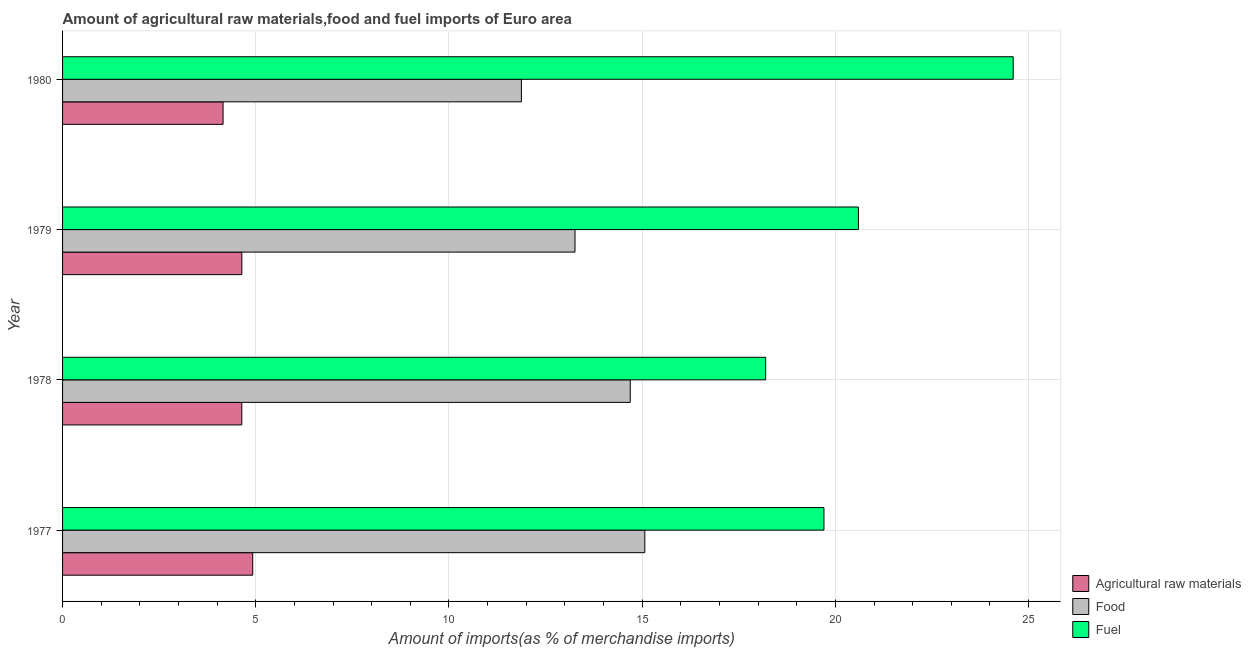Are the number of bars per tick equal to the number of legend labels?
Give a very brief answer. Yes. Are the number of bars on each tick of the Y-axis equal?
Offer a very short reply. Yes. How many bars are there on the 3rd tick from the top?
Provide a succinct answer. 3. What is the label of the 4th group of bars from the top?
Your answer should be compact. 1977. What is the percentage of food imports in 1978?
Your answer should be compact. 14.69. Across all years, what is the maximum percentage of food imports?
Offer a very short reply. 15.07. Across all years, what is the minimum percentage of raw materials imports?
Your answer should be compact. 4.15. What is the total percentage of food imports in the graph?
Give a very brief answer. 54.9. What is the difference between the percentage of raw materials imports in 1978 and that in 1980?
Offer a terse response. 0.48. What is the difference between the percentage of raw materials imports in 1979 and the percentage of fuel imports in 1980?
Offer a very short reply. -19.96. What is the average percentage of food imports per year?
Your response must be concise. 13.72. In the year 1979, what is the difference between the percentage of fuel imports and percentage of food imports?
Offer a terse response. 7.33. What is the ratio of the percentage of food imports in 1979 to that in 1980?
Provide a short and direct response. 1.12. Is the percentage of food imports in 1979 less than that in 1980?
Provide a short and direct response. No. What is the difference between the highest and the second highest percentage of food imports?
Offer a terse response. 0.38. What is the difference between the highest and the lowest percentage of fuel imports?
Offer a terse response. 6.41. In how many years, is the percentage of raw materials imports greater than the average percentage of raw materials imports taken over all years?
Your answer should be compact. 3. What does the 1st bar from the top in 1980 represents?
Keep it short and to the point. Fuel. What does the 2nd bar from the bottom in 1980 represents?
Give a very brief answer. Food. Is it the case that in every year, the sum of the percentage of raw materials imports and percentage of food imports is greater than the percentage of fuel imports?
Offer a terse response. No. How many years are there in the graph?
Give a very brief answer. 4. Where does the legend appear in the graph?
Keep it short and to the point. Bottom right. How many legend labels are there?
Make the answer very short. 3. How are the legend labels stacked?
Give a very brief answer. Vertical. What is the title of the graph?
Keep it short and to the point. Amount of agricultural raw materials,food and fuel imports of Euro area. What is the label or title of the X-axis?
Your answer should be compact. Amount of imports(as % of merchandise imports). What is the Amount of imports(as % of merchandise imports) in Agricultural raw materials in 1977?
Your response must be concise. 4.92. What is the Amount of imports(as % of merchandise imports) in Food in 1977?
Give a very brief answer. 15.07. What is the Amount of imports(as % of merchandise imports) in Fuel in 1977?
Provide a succinct answer. 19.7. What is the Amount of imports(as % of merchandise imports) of Agricultural raw materials in 1978?
Keep it short and to the point. 4.64. What is the Amount of imports(as % of merchandise imports) in Food in 1978?
Keep it short and to the point. 14.69. What is the Amount of imports(as % of merchandise imports) in Fuel in 1978?
Your answer should be very brief. 18.2. What is the Amount of imports(as % of merchandise imports) of Agricultural raw materials in 1979?
Provide a short and direct response. 4.64. What is the Amount of imports(as % of merchandise imports) in Food in 1979?
Give a very brief answer. 13.26. What is the Amount of imports(as % of merchandise imports) of Fuel in 1979?
Give a very brief answer. 20.6. What is the Amount of imports(as % of merchandise imports) of Agricultural raw materials in 1980?
Provide a short and direct response. 4.15. What is the Amount of imports(as % of merchandise imports) in Food in 1980?
Your response must be concise. 11.87. What is the Amount of imports(as % of merchandise imports) in Fuel in 1980?
Your response must be concise. 24.6. Across all years, what is the maximum Amount of imports(as % of merchandise imports) in Agricultural raw materials?
Keep it short and to the point. 4.92. Across all years, what is the maximum Amount of imports(as % of merchandise imports) in Food?
Offer a terse response. 15.07. Across all years, what is the maximum Amount of imports(as % of merchandise imports) in Fuel?
Provide a short and direct response. 24.6. Across all years, what is the minimum Amount of imports(as % of merchandise imports) in Agricultural raw materials?
Provide a short and direct response. 4.15. Across all years, what is the minimum Amount of imports(as % of merchandise imports) of Food?
Keep it short and to the point. 11.87. Across all years, what is the minimum Amount of imports(as % of merchandise imports) of Fuel?
Ensure brevity in your answer.  18.2. What is the total Amount of imports(as % of merchandise imports) of Agricultural raw materials in the graph?
Your answer should be compact. 18.35. What is the total Amount of imports(as % of merchandise imports) in Food in the graph?
Offer a terse response. 54.9. What is the total Amount of imports(as % of merchandise imports) in Fuel in the graph?
Your response must be concise. 83.1. What is the difference between the Amount of imports(as % of merchandise imports) in Agricultural raw materials in 1977 and that in 1978?
Your response must be concise. 0.28. What is the difference between the Amount of imports(as % of merchandise imports) in Food in 1977 and that in 1978?
Your response must be concise. 0.38. What is the difference between the Amount of imports(as % of merchandise imports) in Fuel in 1977 and that in 1978?
Your response must be concise. 1.51. What is the difference between the Amount of imports(as % of merchandise imports) in Agricultural raw materials in 1977 and that in 1979?
Make the answer very short. 0.28. What is the difference between the Amount of imports(as % of merchandise imports) in Food in 1977 and that in 1979?
Give a very brief answer. 1.81. What is the difference between the Amount of imports(as % of merchandise imports) of Fuel in 1977 and that in 1979?
Provide a succinct answer. -0.89. What is the difference between the Amount of imports(as % of merchandise imports) in Agricultural raw materials in 1977 and that in 1980?
Offer a very short reply. 0.77. What is the difference between the Amount of imports(as % of merchandise imports) of Food in 1977 and that in 1980?
Provide a short and direct response. 3.19. What is the difference between the Amount of imports(as % of merchandise imports) in Fuel in 1977 and that in 1980?
Provide a short and direct response. -4.9. What is the difference between the Amount of imports(as % of merchandise imports) in Agricultural raw materials in 1978 and that in 1979?
Keep it short and to the point. -0. What is the difference between the Amount of imports(as % of merchandise imports) in Food in 1978 and that in 1979?
Give a very brief answer. 1.43. What is the difference between the Amount of imports(as % of merchandise imports) of Fuel in 1978 and that in 1979?
Give a very brief answer. -2.4. What is the difference between the Amount of imports(as % of merchandise imports) in Agricultural raw materials in 1978 and that in 1980?
Ensure brevity in your answer.  0.48. What is the difference between the Amount of imports(as % of merchandise imports) in Food in 1978 and that in 1980?
Your answer should be compact. 2.82. What is the difference between the Amount of imports(as % of merchandise imports) of Fuel in 1978 and that in 1980?
Your answer should be very brief. -6.41. What is the difference between the Amount of imports(as % of merchandise imports) of Agricultural raw materials in 1979 and that in 1980?
Provide a succinct answer. 0.49. What is the difference between the Amount of imports(as % of merchandise imports) in Food in 1979 and that in 1980?
Your response must be concise. 1.39. What is the difference between the Amount of imports(as % of merchandise imports) in Fuel in 1979 and that in 1980?
Offer a terse response. -4.01. What is the difference between the Amount of imports(as % of merchandise imports) in Agricultural raw materials in 1977 and the Amount of imports(as % of merchandise imports) in Food in 1978?
Provide a short and direct response. -9.77. What is the difference between the Amount of imports(as % of merchandise imports) in Agricultural raw materials in 1977 and the Amount of imports(as % of merchandise imports) in Fuel in 1978?
Provide a short and direct response. -13.27. What is the difference between the Amount of imports(as % of merchandise imports) of Food in 1977 and the Amount of imports(as % of merchandise imports) of Fuel in 1978?
Offer a terse response. -3.13. What is the difference between the Amount of imports(as % of merchandise imports) of Agricultural raw materials in 1977 and the Amount of imports(as % of merchandise imports) of Food in 1979?
Provide a succinct answer. -8.34. What is the difference between the Amount of imports(as % of merchandise imports) of Agricultural raw materials in 1977 and the Amount of imports(as % of merchandise imports) of Fuel in 1979?
Ensure brevity in your answer.  -15.68. What is the difference between the Amount of imports(as % of merchandise imports) of Food in 1977 and the Amount of imports(as % of merchandise imports) of Fuel in 1979?
Provide a succinct answer. -5.53. What is the difference between the Amount of imports(as % of merchandise imports) in Agricultural raw materials in 1977 and the Amount of imports(as % of merchandise imports) in Food in 1980?
Offer a terse response. -6.95. What is the difference between the Amount of imports(as % of merchandise imports) in Agricultural raw materials in 1977 and the Amount of imports(as % of merchandise imports) in Fuel in 1980?
Provide a succinct answer. -19.68. What is the difference between the Amount of imports(as % of merchandise imports) of Food in 1977 and the Amount of imports(as % of merchandise imports) of Fuel in 1980?
Ensure brevity in your answer.  -9.53. What is the difference between the Amount of imports(as % of merchandise imports) in Agricultural raw materials in 1978 and the Amount of imports(as % of merchandise imports) in Food in 1979?
Your answer should be very brief. -8.62. What is the difference between the Amount of imports(as % of merchandise imports) in Agricultural raw materials in 1978 and the Amount of imports(as % of merchandise imports) in Fuel in 1979?
Offer a very short reply. -15.96. What is the difference between the Amount of imports(as % of merchandise imports) in Food in 1978 and the Amount of imports(as % of merchandise imports) in Fuel in 1979?
Your response must be concise. -5.91. What is the difference between the Amount of imports(as % of merchandise imports) of Agricultural raw materials in 1978 and the Amount of imports(as % of merchandise imports) of Food in 1980?
Your answer should be very brief. -7.24. What is the difference between the Amount of imports(as % of merchandise imports) in Agricultural raw materials in 1978 and the Amount of imports(as % of merchandise imports) in Fuel in 1980?
Offer a terse response. -19.96. What is the difference between the Amount of imports(as % of merchandise imports) of Food in 1978 and the Amount of imports(as % of merchandise imports) of Fuel in 1980?
Make the answer very short. -9.91. What is the difference between the Amount of imports(as % of merchandise imports) in Agricultural raw materials in 1979 and the Amount of imports(as % of merchandise imports) in Food in 1980?
Ensure brevity in your answer.  -7.23. What is the difference between the Amount of imports(as % of merchandise imports) in Agricultural raw materials in 1979 and the Amount of imports(as % of merchandise imports) in Fuel in 1980?
Give a very brief answer. -19.96. What is the difference between the Amount of imports(as % of merchandise imports) of Food in 1979 and the Amount of imports(as % of merchandise imports) of Fuel in 1980?
Offer a very short reply. -11.34. What is the average Amount of imports(as % of merchandise imports) of Agricultural raw materials per year?
Your answer should be very brief. 4.59. What is the average Amount of imports(as % of merchandise imports) in Food per year?
Make the answer very short. 13.72. What is the average Amount of imports(as % of merchandise imports) of Fuel per year?
Offer a terse response. 20.78. In the year 1977, what is the difference between the Amount of imports(as % of merchandise imports) of Agricultural raw materials and Amount of imports(as % of merchandise imports) of Food?
Your response must be concise. -10.15. In the year 1977, what is the difference between the Amount of imports(as % of merchandise imports) of Agricultural raw materials and Amount of imports(as % of merchandise imports) of Fuel?
Offer a terse response. -14.78. In the year 1977, what is the difference between the Amount of imports(as % of merchandise imports) of Food and Amount of imports(as % of merchandise imports) of Fuel?
Provide a short and direct response. -4.64. In the year 1978, what is the difference between the Amount of imports(as % of merchandise imports) of Agricultural raw materials and Amount of imports(as % of merchandise imports) of Food?
Your answer should be compact. -10.05. In the year 1978, what is the difference between the Amount of imports(as % of merchandise imports) in Agricultural raw materials and Amount of imports(as % of merchandise imports) in Fuel?
Ensure brevity in your answer.  -13.56. In the year 1978, what is the difference between the Amount of imports(as % of merchandise imports) of Food and Amount of imports(as % of merchandise imports) of Fuel?
Give a very brief answer. -3.5. In the year 1979, what is the difference between the Amount of imports(as % of merchandise imports) of Agricultural raw materials and Amount of imports(as % of merchandise imports) of Food?
Your response must be concise. -8.62. In the year 1979, what is the difference between the Amount of imports(as % of merchandise imports) in Agricultural raw materials and Amount of imports(as % of merchandise imports) in Fuel?
Offer a terse response. -15.96. In the year 1979, what is the difference between the Amount of imports(as % of merchandise imports) in Food and Amount of imports(as % of merchandise imports) in Fuel?
Offer a very short reply. -7.34. In the year 1980, what is the difference between the Amount of imports(as % of merchandise imports) in Agricultural raw materials and Amount of imports(as % of merchandise imports) in Food?
Your answer should be compact. -7.72. In the year 1980, what is the difference between the Amount of imports(as % of merchandise imports) of Agricultural raw materials and Amount of imports(as % of merchandise imports) of Fuel?
Ensure brevity in your answer.  -20.45. In the year 1980, what is the difference between the Amount of imports(as % of merchandise imports) in Food and Amount of imports(as % of merchandise imports) in Fuel?
Give a very brief answer. -12.73. What is the ratio of the Amount of imports(as % of merchandise imports) of Agricultural raw materials in 1977 to that in 1978?
Make the answer very short. 1.06. What is the ratio of the Amount of imports(as % of merchandise imports) in Food in 1977 to that in 1978?
Make the answer very short. 1.03. What is the ratio of the Amount of imports(as % of merchandise imports) in Fuel in 1977 to that in 1978?
Keep it short and to the point. 1.08. What is the ratio of the Amount of imports(as % of merchandise imports) of Agricultural raw materials in 1977 to that in 1979?
Keep it short and to the point. 1.06. What is the ratio of the Amount of imports(as % of merchandise imports) in Food in 1977 to that in 1979?
Ensure brevity in your answer.  1.14. What is the ratio of the Amount of imports(as % of merchandise imports) in Fuel in 1977 to that in 1979?
Make the answer very short. 0.96. What is the ratio of the Amount of imports(as % of merchandise imports) in Agricultural raw materials in 1977 to that in 1980?
Your answer should be compact. 1.18. What is the ratio of the Amount of imports(as % of merchandise imports) of Food in 1977 to that in 1980?
Offer a terse response. 1.27. What is the ratio of the Amount of imports(as % of merchandise imports) of Fuel in 1977 to that in 1980?
Ensure brevity in your answer.  0.8. What is the ratio of the Amount of imports(as % of merchandise imports) in Food in 1978 to that in 1979?
Your response must be concise. 1.11. What is the ratio of the Amount of imports(as % of merchandise imports) of Fuel in 1978 to that in 1979?
Your answer should be very brief. 0.88. What is the ratio of the Amount of imports(as % of merchandise imports) in Agricultural raw materials in 1978 to that in 1980?
Offer a very short reply. 1.12. What is the ratio of the Amount of imports(as % of merchandise imports) in Food in 1978 to that in 1980?
Keep it short and to the point. 1.24. What is the ratio of the Amount of imports(as % of merchandise imports) of Fuel in 1978 to that in 1980?
Make the answer very short. 0.74. What is the ratio of the Amount of imports(as % of merchandise imports) in Agricultural raw materials in 1979 to that in 1980?
Make the answer very short. 1.12. What is the ratio of the Amount of imports(as % of merchandise imports) of Food in 1979 to that in 1980?
Your response must be concise. 1.12. What is the ratio of the Amount of imports(as % of merchandise imports) in Fuel in 1979 to that in 1980?
Give a very brief answer. 0.84. What is the difference between the highest and the second highest Amount of imports(as % of merchandise imports) in Agricultural raw materials?
Your response must be concise. 0.28. What is the difference between the highest and the second highest Amount of imports(as % of merchandise imports) in Food?
Your answer should be compact. 0.38. What is the difference between the highest and the second highest Amount of imports(as % of merchandise imports) of Fuel?
Offer a very short reply. 4.01. What is the difference between the highest and the lowest Amount of imports(as % of merchandise imports) of Agricultural raw materials?
Provide a short and direct response. 0.77. What is the difference between the highest and the lowest Amount of imports(as % of merchandise imports) of Food?
Ensure brevity in your answer.  3.19. What is the difference between the highest and the lowest Amount of imports(as % of merchandise imports) of Fuel?
Your answer should be very brief. 6.41. 